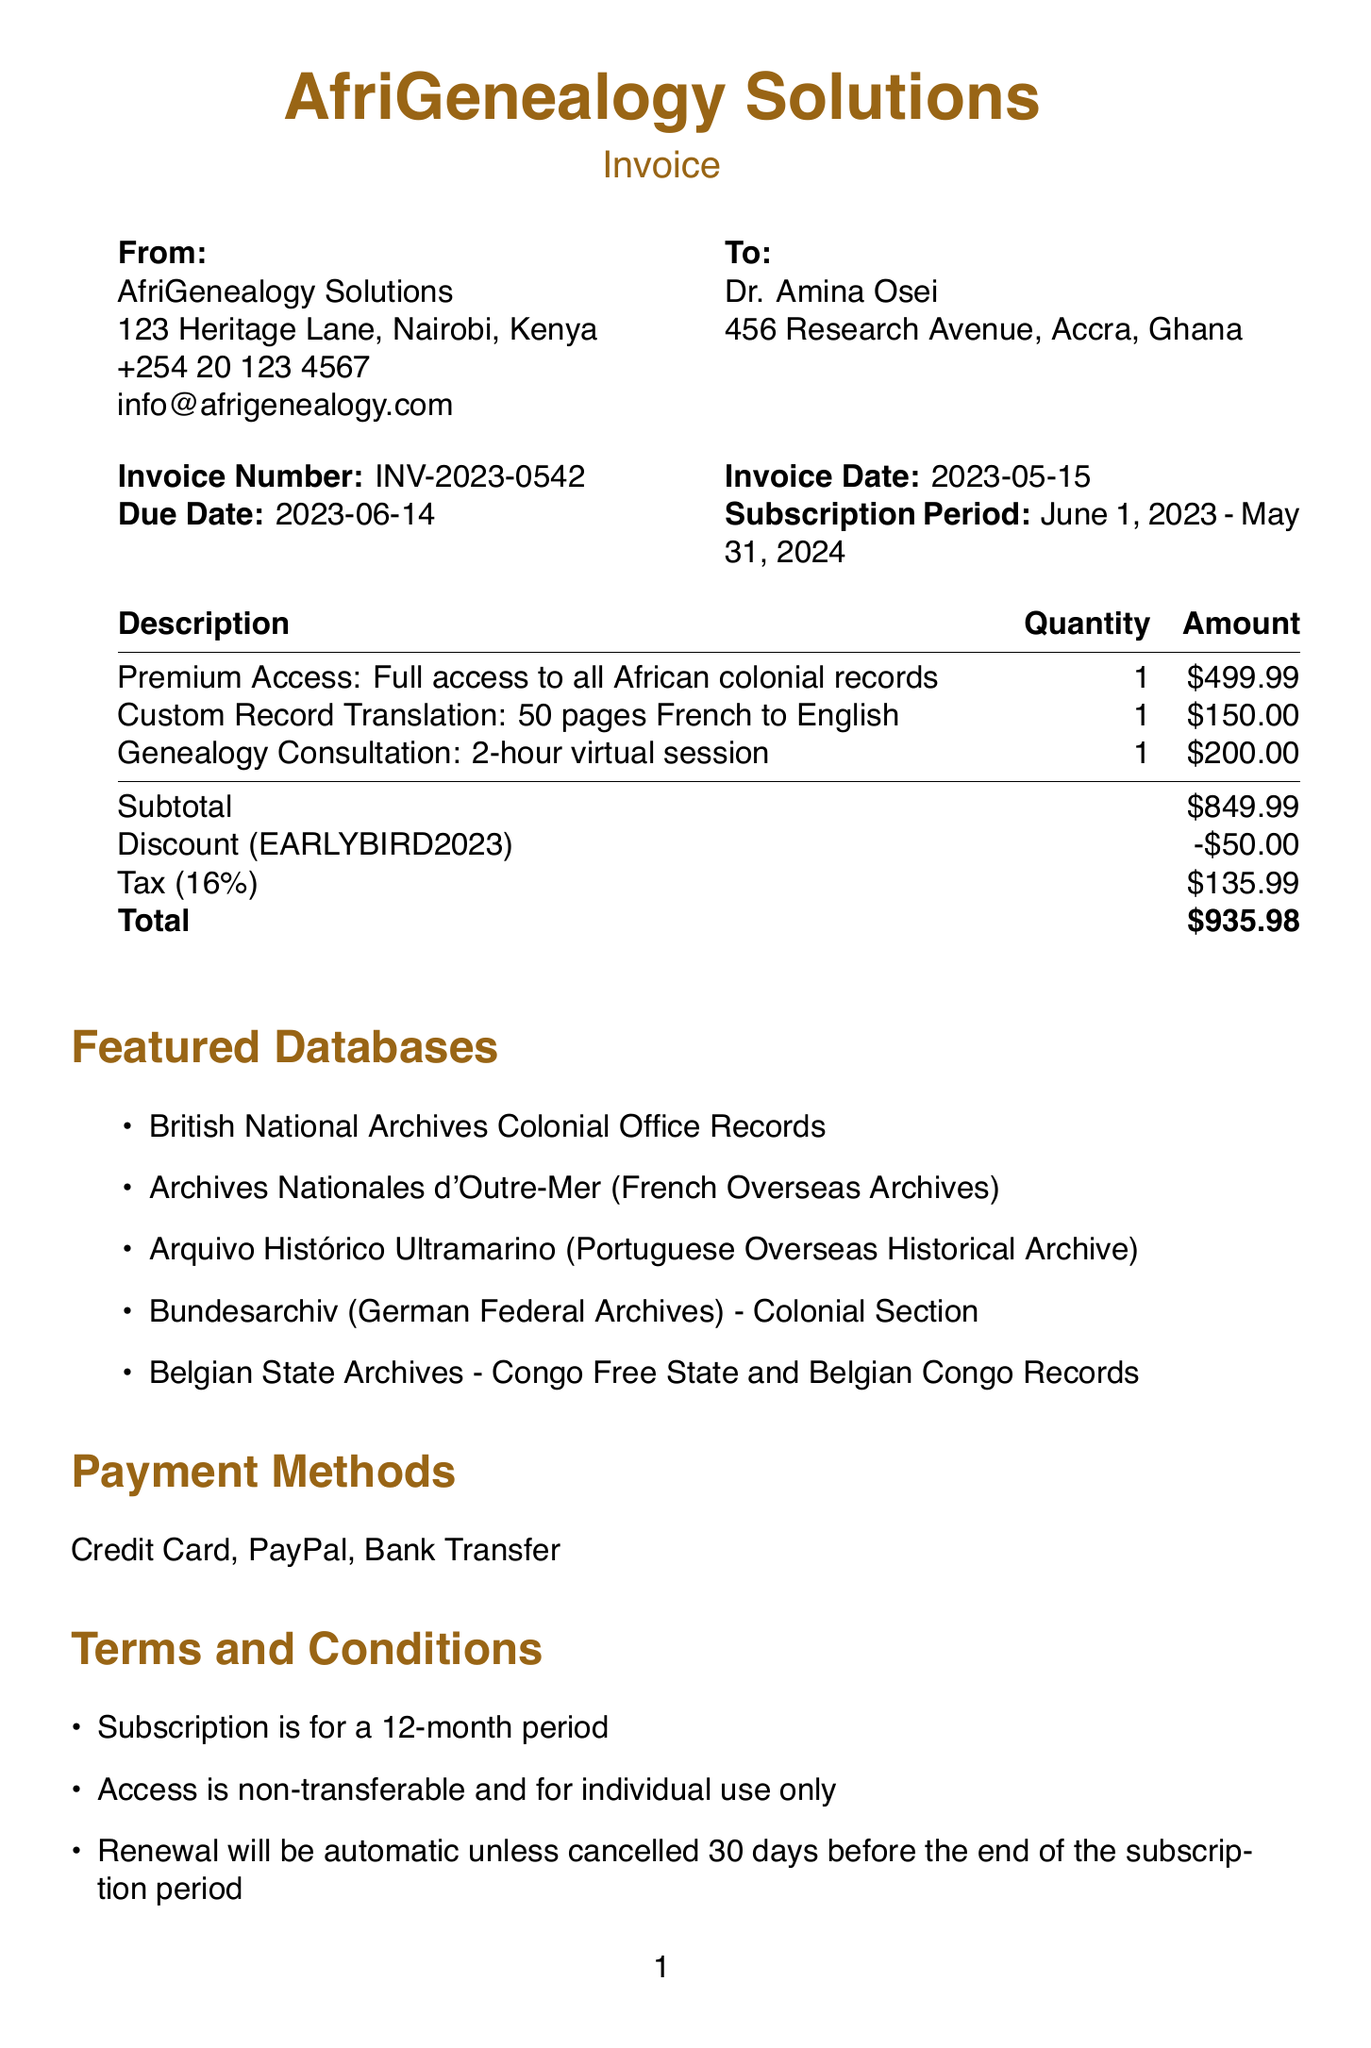What is the invoice number? The invoice number is listed in the document as a specific identifier for the transaction.
Answer: INV-2023-0542 What is the total amount due? The total amount is the final figure calculated after applying the discount and tax.
Answer: $935.98 Who is the customer? The document specifies the name of the customer receiving the invoice.
Answer: Dr. Amina Osei What is the price of the Premium Access tier? The document states the price for the selected subscription tier, which is defined under the subscription tier section.
Answer: $499.99 What is the discount amount applied? The discount amount is specified in the invoice under the discount line item, reflecting a reduction in the total.
Answer: $50.00 What is the subscription period? The subscription period indicates the duration for which the service will be provided, explicitly stated in the document.
Answer: June 1, 2023 - May 31, 2024 What service is offered for $200? The document describes this specific service and its corresponding charge under additional services.
Answer: Genealogy Consultation What payment methods are mentioned? The document lists acceptable methods for payment, which can be found in the payment section.
Answer: Credit Card, PayPal, Bank Transfer What is the tax rate applied to the invoice? The tax rate is explicitly mentioned in the invoice documents, which affects the final total calculation.
Answer: 16% 